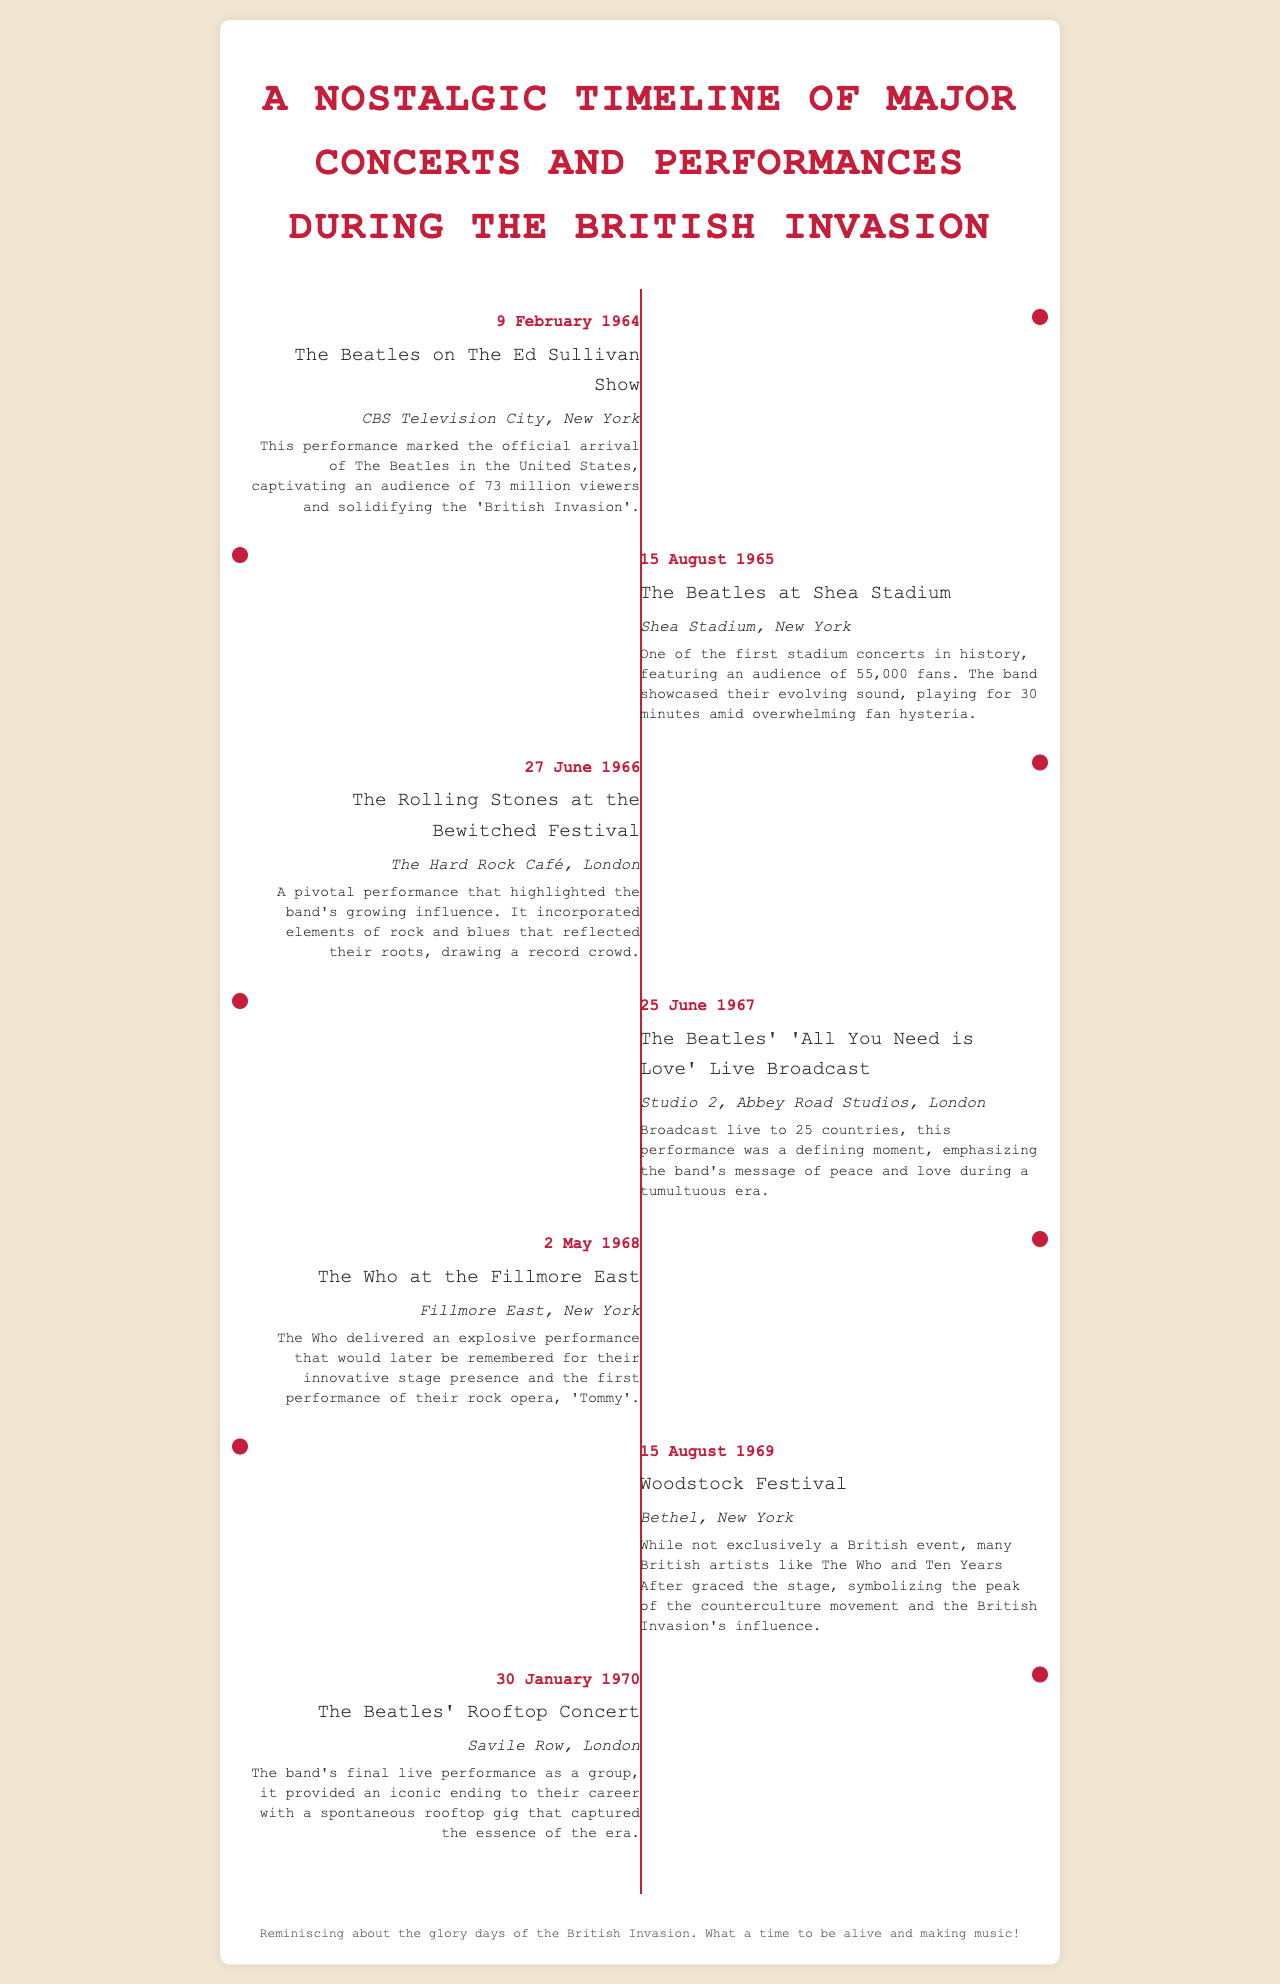What date was The Beatles' performance on The Ed Sullivan Show? The document states that this performance took place on 9 February 1964.
Answer: 9 February 1964 What venue hosted The Beatles' Shea Stadium concert? The document mentions that this concert was held at Shea Stadium, New York.
Answer: Shea Stadium, New York What was significant about The Beatles' live broadcast of 'All You Need is Love'? This performance was broadcast live to 25 countries, emphasizing the band's message of peace and love.
Answer: Broadcast live to 25 countries How many fans attended The Beatles' concert at Shea Stadium? The document notes that there were 55,000 fans in attendance at this concert.
Answer: 55,000 fans What notable performance did The Who have in 1968? The document highlights that The Who performed at the Fillmore East in 1968.
Answer: The Who at the Fillmore East What event marked the final live performance of The Beatles? The document specifies that their final live performance was the Rooftop Concert on 30 January 1970.
Answer: Rooftop Concert Which British band's performance was highlighted at the Woodstock Festival? The document mentions that The Who performed at the Woodstock Festival.
Answer: The Who What was notable about the concert at the Bewitched Festival? The document indicates that it highlighted The Rolling Stones' growing influence and attracted a record crowd.
Answer: Highlighted growing influence How did The Beatles' appearance on The Ed Sullivan Show impact the American audience? According to the document, it captivated an audience of 73 million viewers.
Answer: Captivated 73 million viewers 